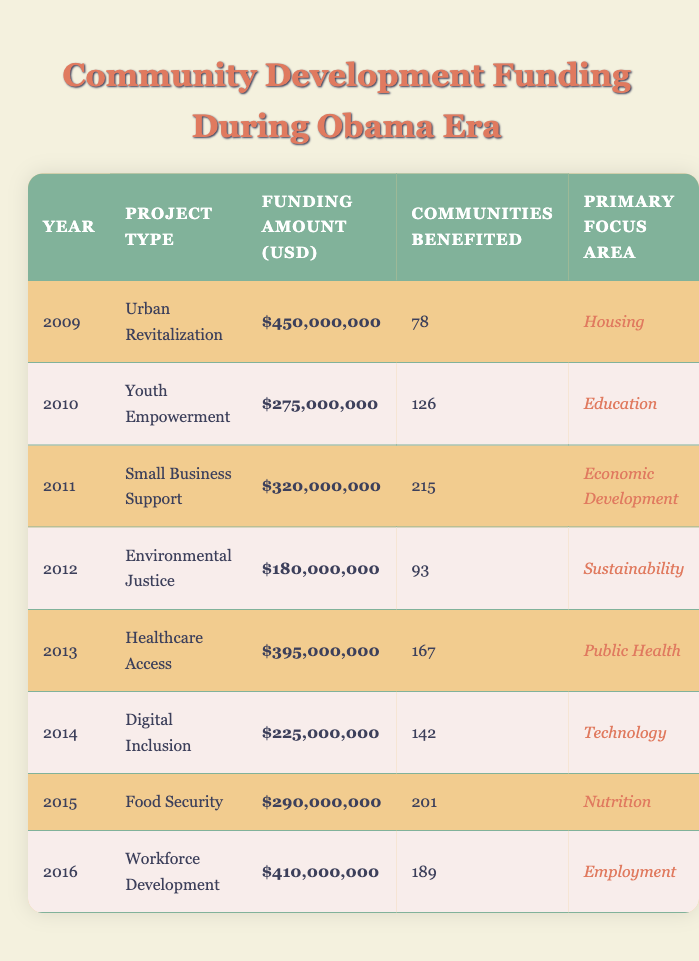What was the total funding amount for community development projects in 2009? According to the table, the funding amount for the year 2009, specifically for Urban Revitalization, is $450,000,000.
Answer: 450,000,000 Which project type benefited the most communities in a single year? The year 2011 has the Small Business Support project, which benefited 215 communities, the highest number among all listed projects.
Answer: Small Business Support What is the average funding amount across all projects listed? To find the average, we add all funding amounts: 450,000,000 + 275,000,000 + 320,000,000 + 180,000,000 + 395,000,000 + 225,000,000 + 290,000,000 + 410,000,000 = 2,555,000,000. With 8 projects, we divide this total by 8, yielding an average of 319,375,000.
Answer: 319,375,000 Did the project focused on Digital Inclusion receive more or less funding than the project focused on Environmental Justice? The funding for Digital Inclusion in 2014 is $225,000,000, while Environmental Justice in 2012 received $180,000,000. Since 225,000,000 is greater than 180,000,000, Digital Inclusion received more funding.
Answer: Yes What was the total number of communities that benefited from all projects combined from 2009 to 2016? To find the total, we sum the communities benefited: 78 + 126 + 215 + 93 + 167 + 142 + 201 + 189 = 1,211 communities benefited in total from all projects.
Answer: 1,211 